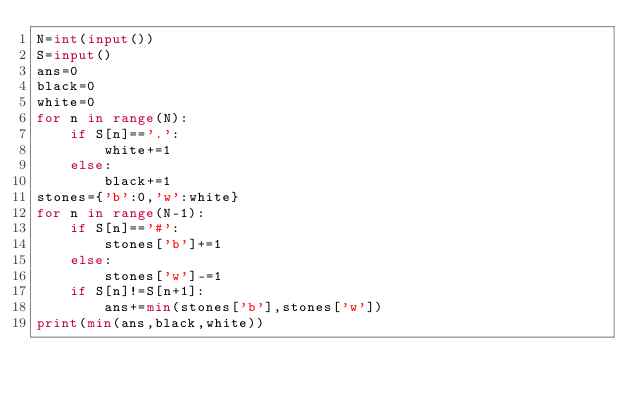Convert code to text. <code><loc_0><loc_0><loc_500><loc_500><_Python_>N=int(input())
S=input()
ans=0
black=0
white=0
for n in range(N):
    if S[n]=='.':
        white+=1
    else:
        black+=1
stones={'b':0,'w':white}
for n in range(N-1):
    if S[n]=='#':
        stones['b']+=1
    else:
        stones['w']-=1
    if S[n]!=S[n+1]:
        ans+=min(stones['b'],stones['w'])
print(min(ans,black,white))
</code> 